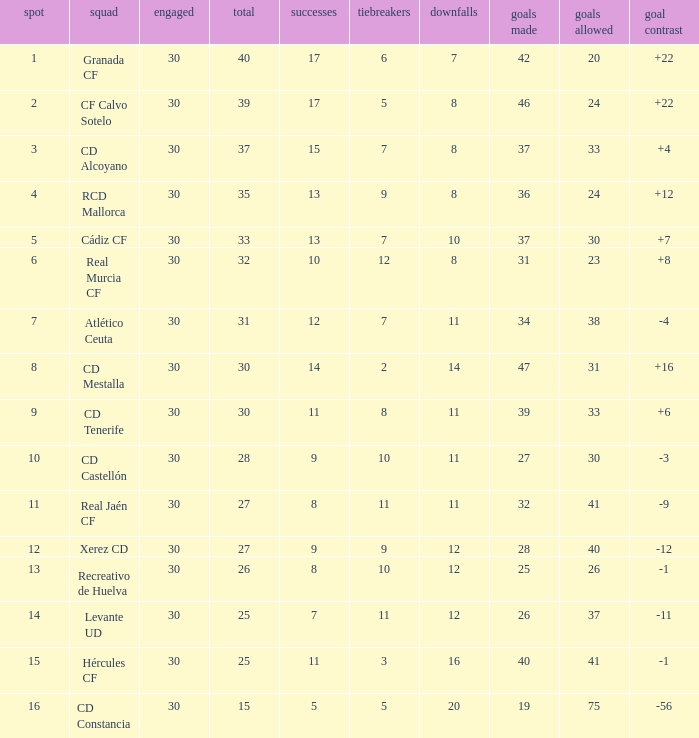How many Wins have Goals against smaller than 30, and Goals for larger than 25, and Draws larger than 5? 3.0. 